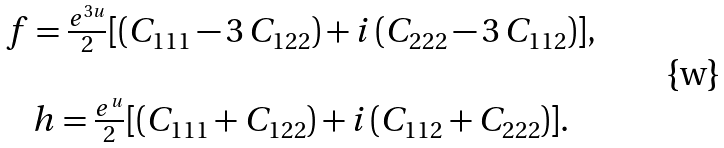<formula> <loc_0><loc_0><loc_500><loc_500>\begin{array} { c } f = \frac { e ^ { 3 u } } { 2 } [ ( C _ { 1 1 1 } - 3 \, C _ { 1 2 2 } ) + i \, ( C _ { 2 2 2 } - 3 \, C _ { 1 1 2 } ) ] , \\ \\ h = \frac { e ^ { u } } { 2 } [ ( C _ { 1 1 1 } + C _ { 1 2 2 } ) + i \, ( C _ { 1 1 2 } + C _ { 2 2 2 } ) ] . \end{array}</formula> 